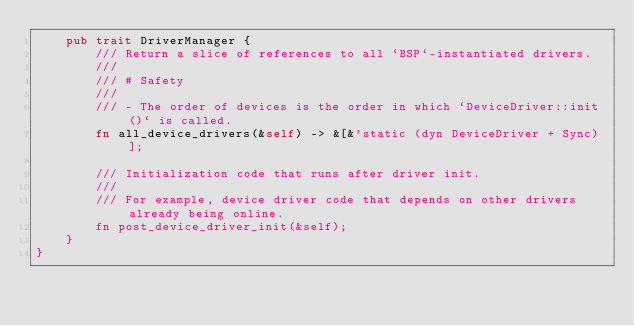Convert code to text. <code><loc_0><loc_0><loc_500><loc_500><_Rust_>    pub trait DriverManager {
        /// Return a slice of references to all `BSP`-instantiated drivers.
        ///
        /// # Safety
        ///
        /// - The order of devices is the order in which `DeviceDriver::init()` is called.
        fn all_device_drivers(&self) -> &[&'static (dyn DeviceDriver + Sync)];

        /// Initialization code that runs after driver init.
        ///
        /// For example, device driver code that depends on other drivers already being online.
        fn post_device_driver_init(&self);
    }
}
</code> 